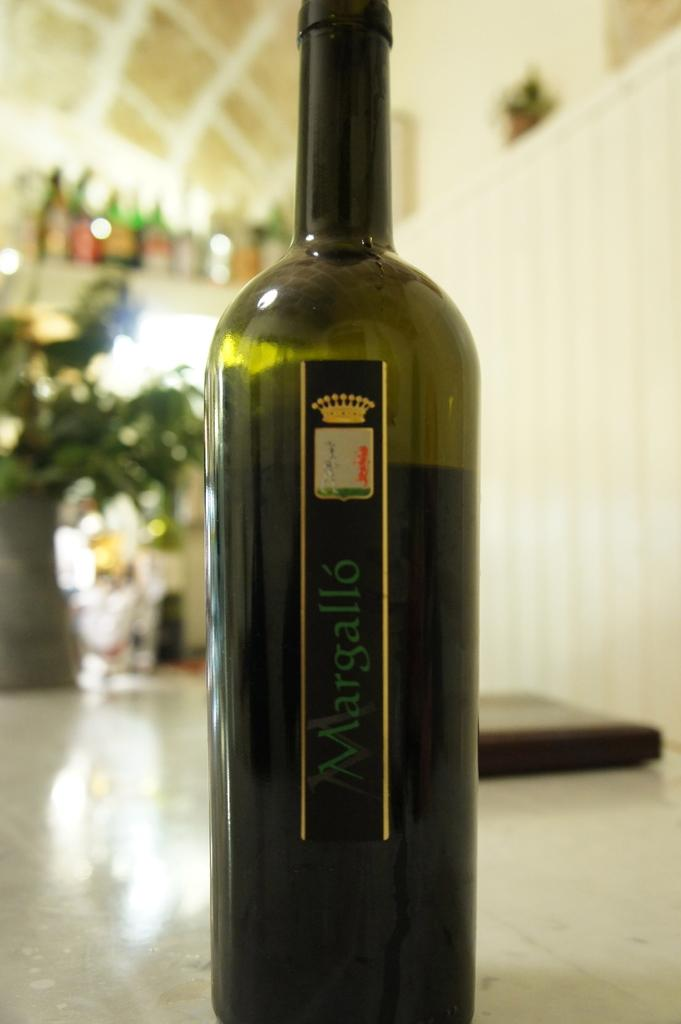What is the main object in the image? There is a bottle in the image. What is written on the bottle? The bottle has "marghello" written on it. What color is the bottle? The bottle is green in color. What type of vegetation is on the left side of the image? There are shrubs on the left side of the image. How many bottles are visible on the top of the image? There are multiple bottles visible on the top of the image. How many pets are sitting on the chairs in the image? There are no pets or chairs present in the image. What type of army is depicted in the image? There is no army depicted in the image; it features a bottle and shrubs. 